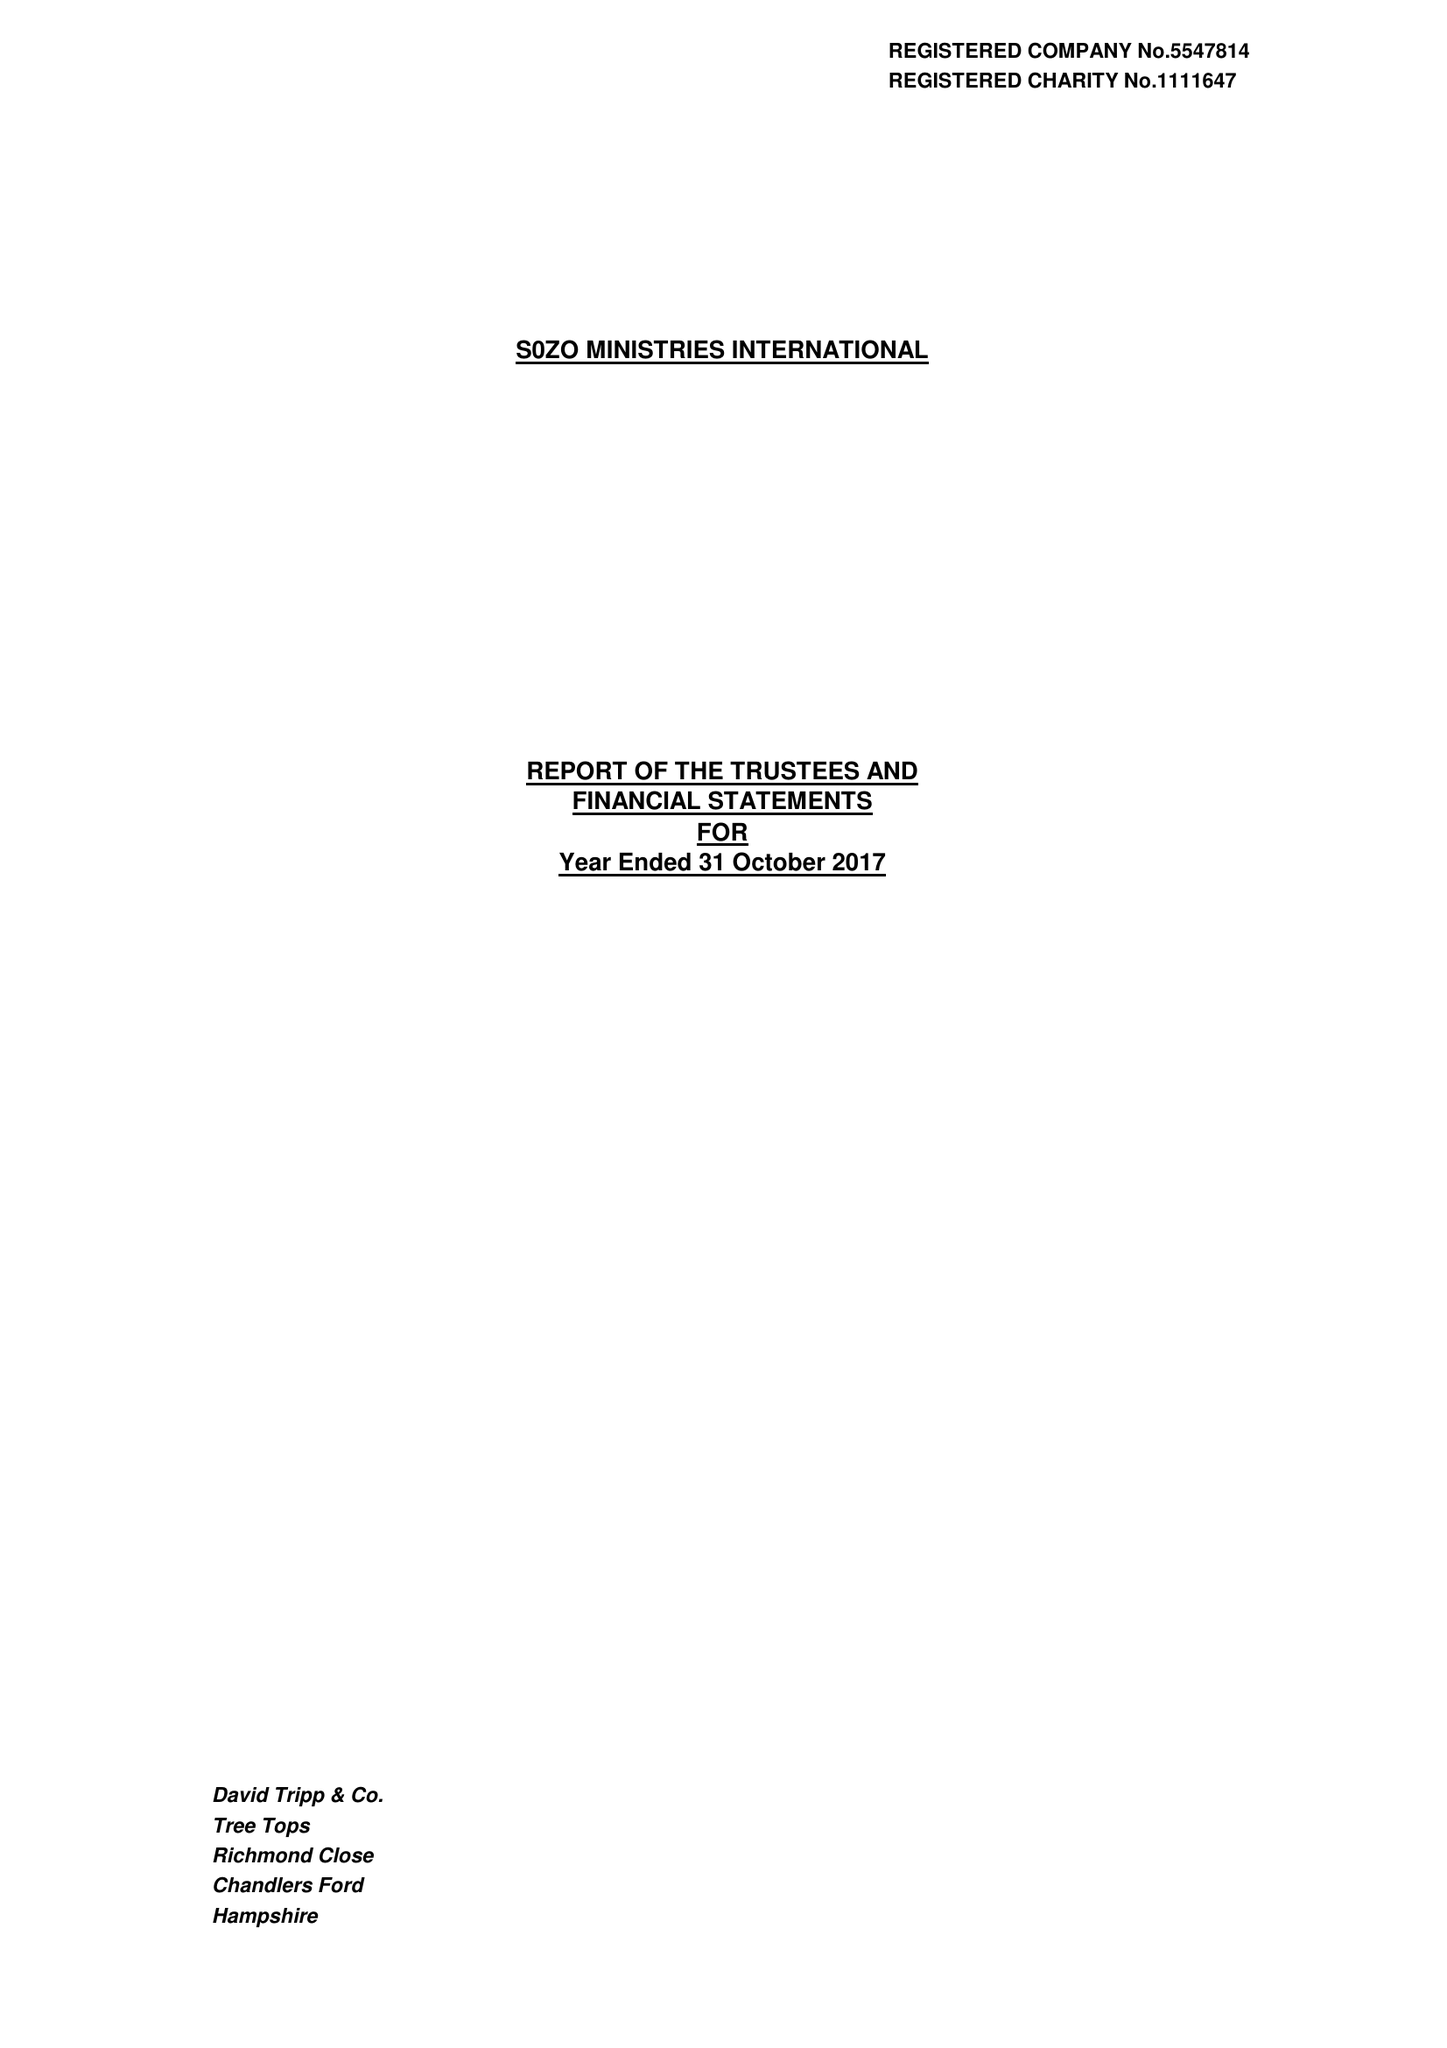What is the value for the charity_name?
Answer the question using a single word or phrase. Sozo Ministries International 